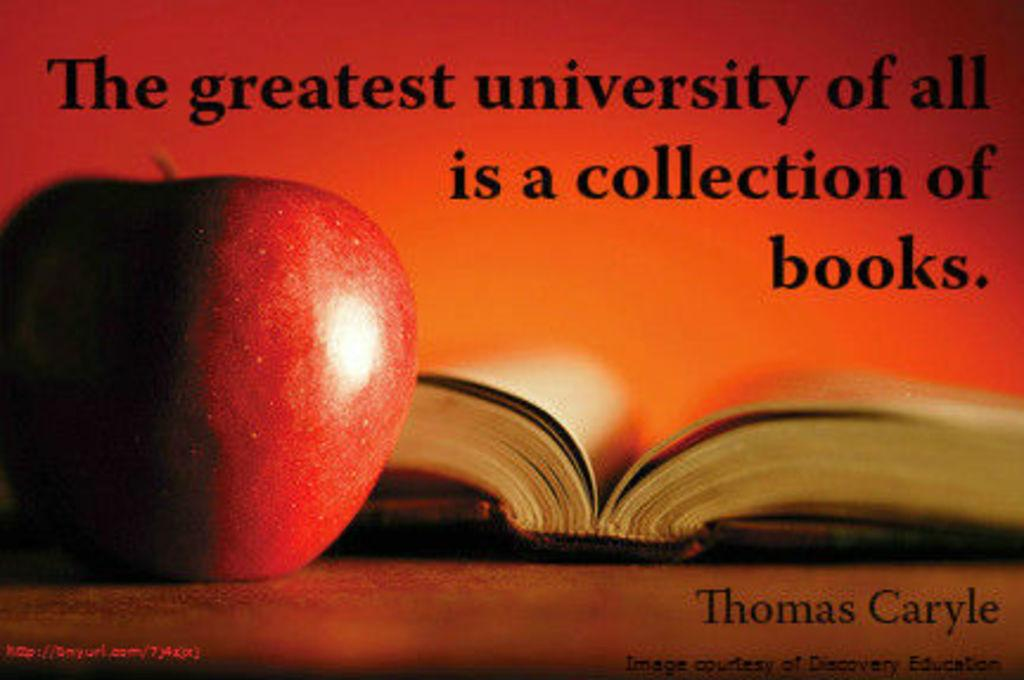What object is on the table in the image? There is an apple and a book on the table in the image. What can be found on the table besides the apple and book? There is no other object mentioned in the provided facts. What is written on the top of the image? There is text on the top of the image. What is written on the bottom of the image? There is text on the bottom of the image. How many crayons are visible in the image? There is no mention of crayons in the provided facts, so we cannot determine their presence or quantity in the image. 